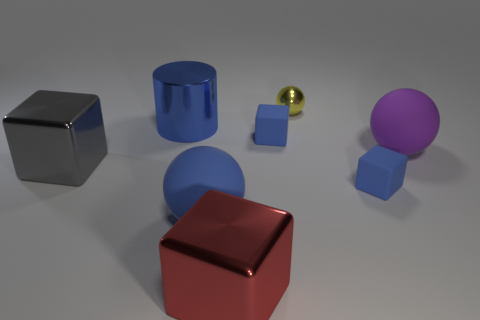What number of cylinders are tiny blue matte objects or big things?
Offer a very short reply. 1. There is a ball that is the same color as the large shiny cylinder; what is it made of?
Your answer should be very brief. Rubber. Is the shape of the big thing that is on the right side of the large red block the same as the large rubber object that is in front of the large gray metallic cube?
Provide a short and direct response. Yes. The large metallic thing that is behind the large blue sphere and to the right of the gray object is what color?
Ensure brevity in your answer.  Blue. There is a big metal cylinder; does it have the same color as the tiny matte object behind the purple matte sphere?
Make the answer very short. Yes. How big is the shiny object that is both behind the red metallic cube and in front of the large purple rubber ball?
Give a very brief answer. Large. What number of other objects are the same color as the metal sphere?
Ensure brevity in your answer.  0. There is a matte ball that is right of the large ball left of the small blue cube on the left side of the tiny yellow object; what is its size?
Your answer should be very brief. Large. There is a tiny yellow object; are there any tiny spheres to the right of it?
Your response must be concise. No. Does the blue cylinder have the same size as the blue cube in front of the big gray metallic object?
Offer a very short reply. No. 